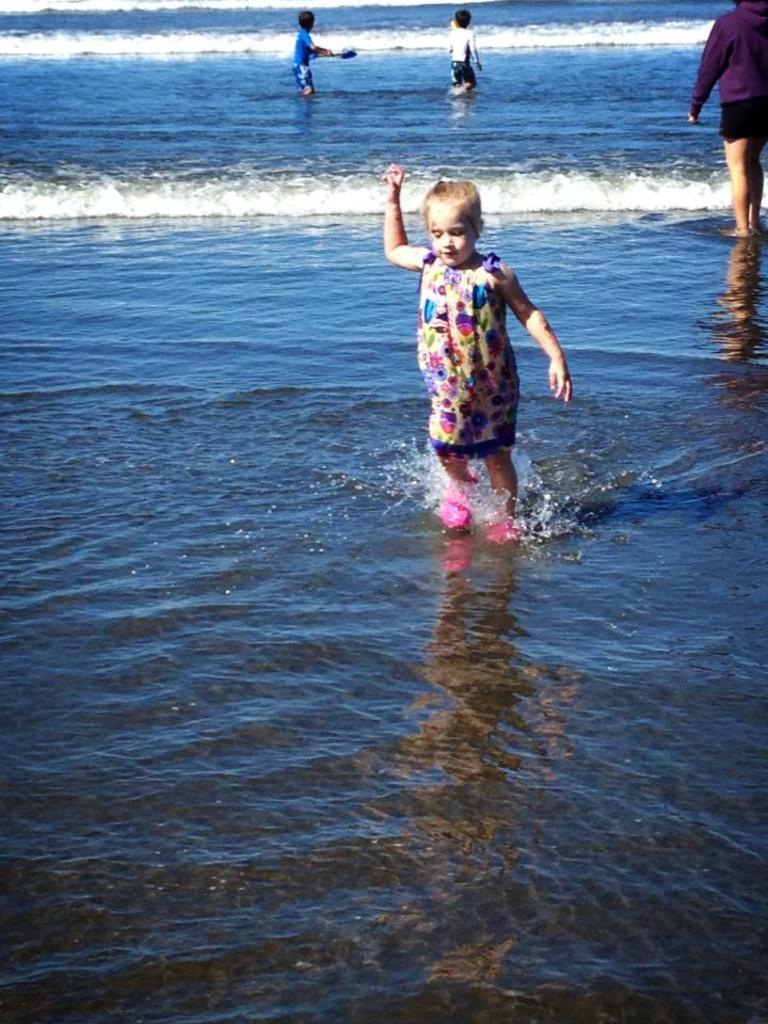Could you give a brief overview of what you see in this image? In this image we can see the sea, one boy in blue T-shirt standing in the water and holding one object. There is one girl with pink shoes walking in the water, one boy walking in the water and on the top right side of the image there is a person standing in the water. 